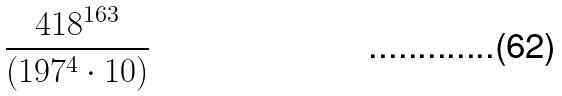Convert formula to latex. <formula><loc_0><loc_0><loc_500><loc_500>\frac { 4 1 8 ^ { 1 6 3 } } { ( 1 9 7 ^ { 4 } \cdot 1 0 ) }</formula> 